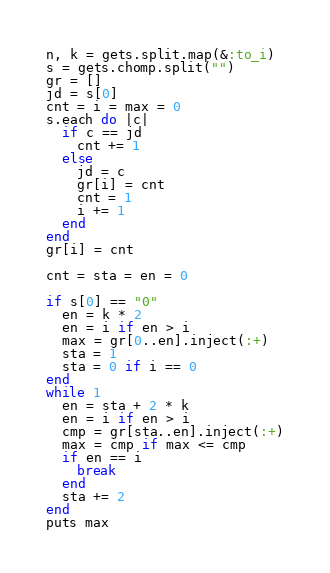Convert code to text. <code><loc_0><loc_0><loc_500><loc_500><_Ruby_>n, k = gets.split.map(&:to_i)
s = gets.chomp.split("")
gr = []
jd = s[0]
cnt = i = max = 0
s.each do |c|
  if c == jd
    cnt += 1
  else
    jd = c
    gr[i] = cnt
    cnt = 1
    i += 1
  end
end
gr[i] = cnt
 
cnt = sta = en = 0

if s[0] == "0"
  en = k * 2
  en = i if en > i
  max = gr[0..en].inject(:+)
  sta = 1
  sta = 0 if i == 0
end
while 1
  en = sta + 2 * k
  en = i if en > i
  cmp = gr[sta..en].inject(:+)
  max = cmp if max <= cmp
  if en == i
    break
  end
  sta += 2
end
puts max</code> 